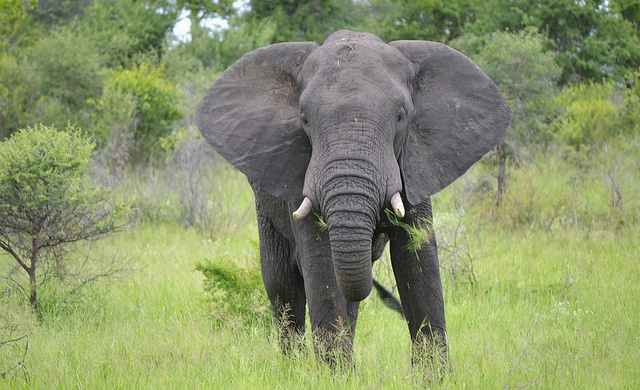Describe the objects in this image and their specific colors. I can see a elephant in olive, gray, and black tones in this image. 